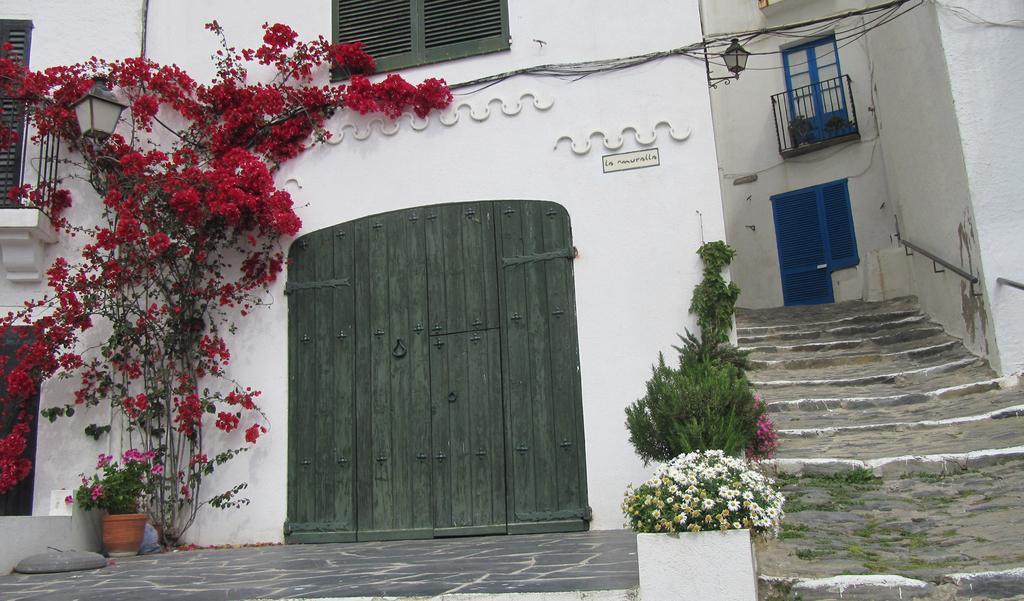Please provide a concise description of this image. There is a house with a window and door, these are plants and stairs. 